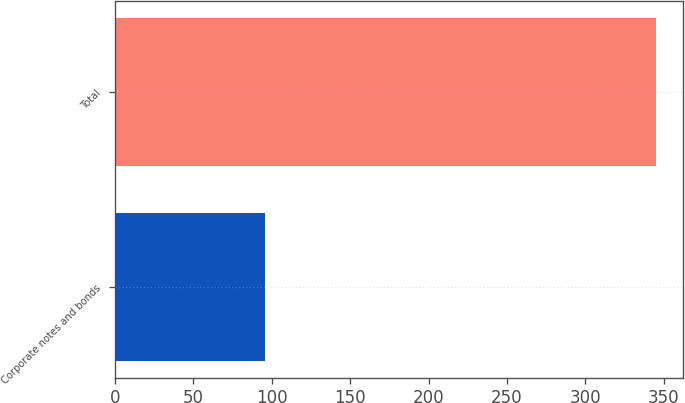<chart> <loc_0><loc_0><loc_500><loc_500><bar_chart><fcel>Corporate notes and bonds<fcel>Total<nl><fcel>96<fcel>345<nl></chart> 